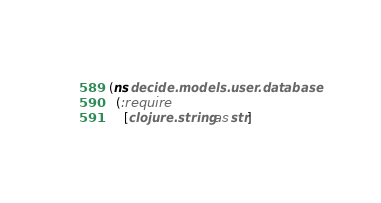<code> <loc_0><loc_0><loc_500><loc_500><_Clojure_>(ns decide.models.user.database
  (:require
    [clojure.string :as str]</code> 